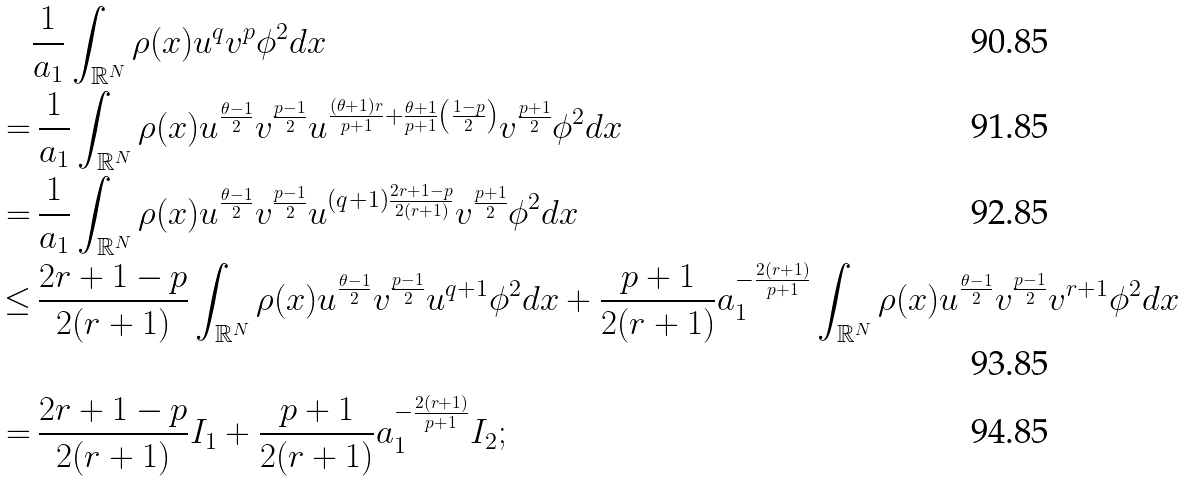<formula> <loc_0><loc_0><loc_500><loc_500>& \frac { 1 } { a _ { 1 } } \int _ { \mathbb { R } ^ { N } } \rho ( x ) u ^ { q } v ^ { p } \phi ^ { 2 } d x \\ = & \, \frac { 1 } { a _ { 1 } } \int _ { \mathbb { R } ^ { N } } \rho ( x ) u ^ { \frac { \theta - 1 } { 2 } } v ^ { \frac { p - 1 } { 2 } } u ^ { \frac { ( \theta + 1 ) r } { p + 1 } + \frac { \theta + 1 } { p + 1 } \left ( \frac { 1 - p } { 2 } \right ) } v ^ { \frac { p + 1 } { 2 } } \phi ^ { 2 } d x \\ = & \, \frac { 1 } { a _ { 1 } } \int _ { \mathbb { R } ^ { N } } \rho ( x ) u ^ { \frac { \theta - 1 } { 2 } } v ^ { \frac { p - 1 } { 2 } } u ^ { ( q + 1 ) \frac { 2 r + 1 - p } { 2 ( r + 1 ) } } v ^ { \frac { p + 1 } { 2 } } \phi ^ { 2 } d x \\ \leq & \, \frac { 2 r + 1 - p } { 2 ( r + 1 ) } \int _ { \mathbb { R } ^ { N } } \rho ( x ) u ^ { \frac { \theta - 1 } { 2 } } v ^ { \frac { p - 1 } { 2 } } u ^ { q + 1 } \phi ^ { 2 } d x + \frac { p + 1 } { 2 ( r + 1 ) } a _ { 1 } ^ { - \frac { 2 ( r + 1 ) } { p + 1 } } \int _ { \mathbb { R } ^ { N } } \rho ( x ) u ^ { \frac { \theta - 1 } { 2 } } v ^ { \frac { p - 1 } { 2 } } v ^ { r + 1 } \phi ^ { 2 } d x \\ = & \, \frac { 2 r + 1 - p } { 2 ( r + 1 ) } I _ { 1 } + \frac { p + 1 } { 2 ( r + 1 ) } a _ { 1 } ^ { - \frac { 2 ( r + 1 ) } { p + 1 } } I _ { 2 } ;</formula> 